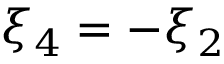Convert formula to latex. <formula><loc_0><loc_0><loc_500><loc_500>\xi _ { 4 } = - \xi _ { 2 }</formula> 